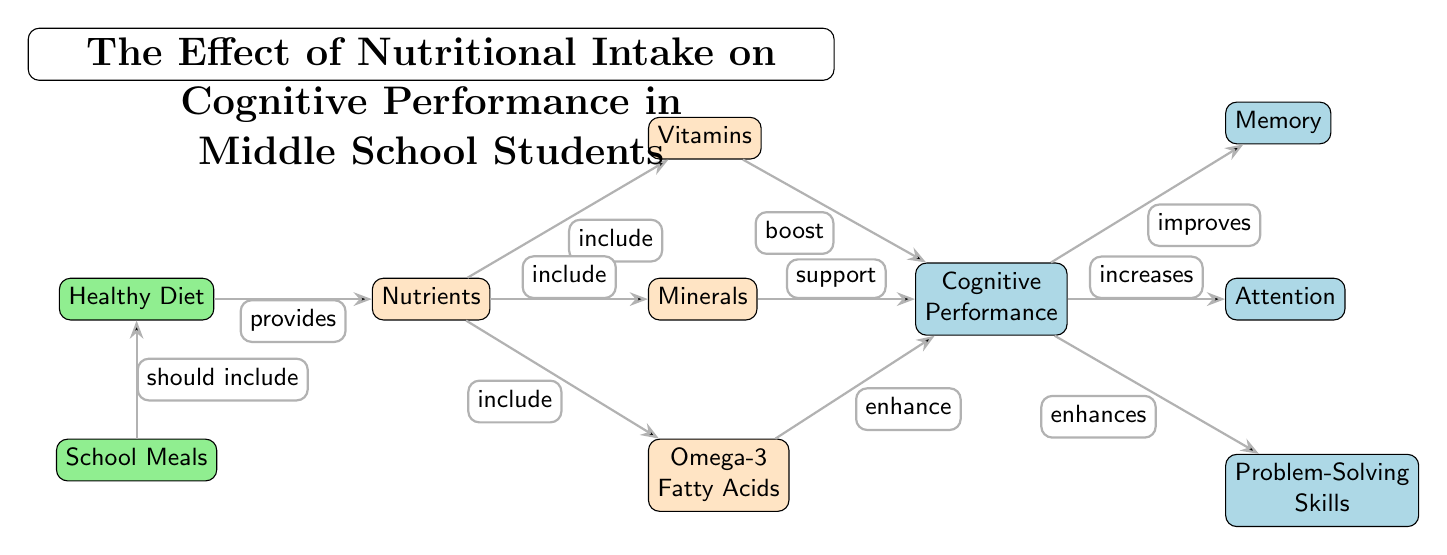What are the three factors included under Nutrients? The diagram shows that Nutrients include Vitamins, Minerals, and Omega-3 Fatty Acids. These connections are indicated by the edges leading from the Nutrients node to each of these specific nutrient nodes.
Answer: Vitamins, Minerals, Omega-3 Fatty Acids How many types of Cognitive Performance are listed in the diagram? The diagram outlines three distinct types of Cognitive Performance: Memory, Attention, and Problem-Solving Skills. These are displayed as separate nodes connected to the Cognitive Performance node.
Answer: Three What does a Healthy Diet provide? According to the diagram, a Healthy Diet provides Nutrients, as indicated by the edge which connects Healthy Diet to Nutrients.
Answer: Nutrients How does Omega-3 Fatty Acids affect Cognitive Performance? The diagram indicates that Omega-3 Fatty Acids enhance Cognitive Performance as represented by the connection between the Omega-3 node and the Cognitive Performance node with the label "enhance".
Answer: Enhance What connection does School Meals have with Healthy Diet? In the diagram, School Meals are connected to a Healthy Diet with the label "should include," suggesting that School Meals ought to consist of elements found in a healthy diet.
Answer: Should include Which nutrient boosts Cognitive Performance? The diagram shows that Vitamins boost Cognitive Performance, as noted by the arrow that connects the Vitamins node to the Cognitive Performance node with the label "boost".
Answer: Boost Which nutrient connects to the most types of Cognitive Performance? The Cognitive Performance node has connections to all three listed types: Memory, Attention, and Problem-Solving Skills. Thus, the factor that connects to the most types is Nutrients, as it influences Cognitive Performance overall, leading to effects witnessed in all three areas.
Answer: Nutrients How are Minerals linked to Cognitive Performance? The diagram specifies that Minerals support Cognitive Performance, as indicated by the edge connecting the Minerals node to Cognitive Performance with the label "support".
Answer: Support 